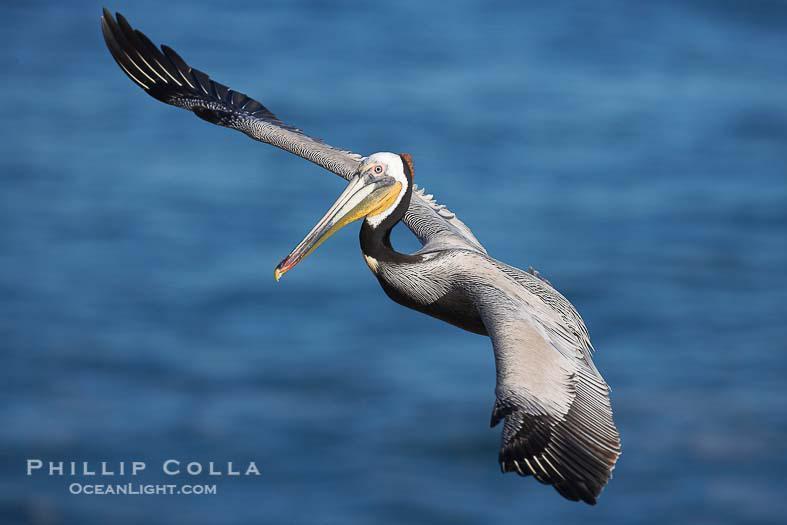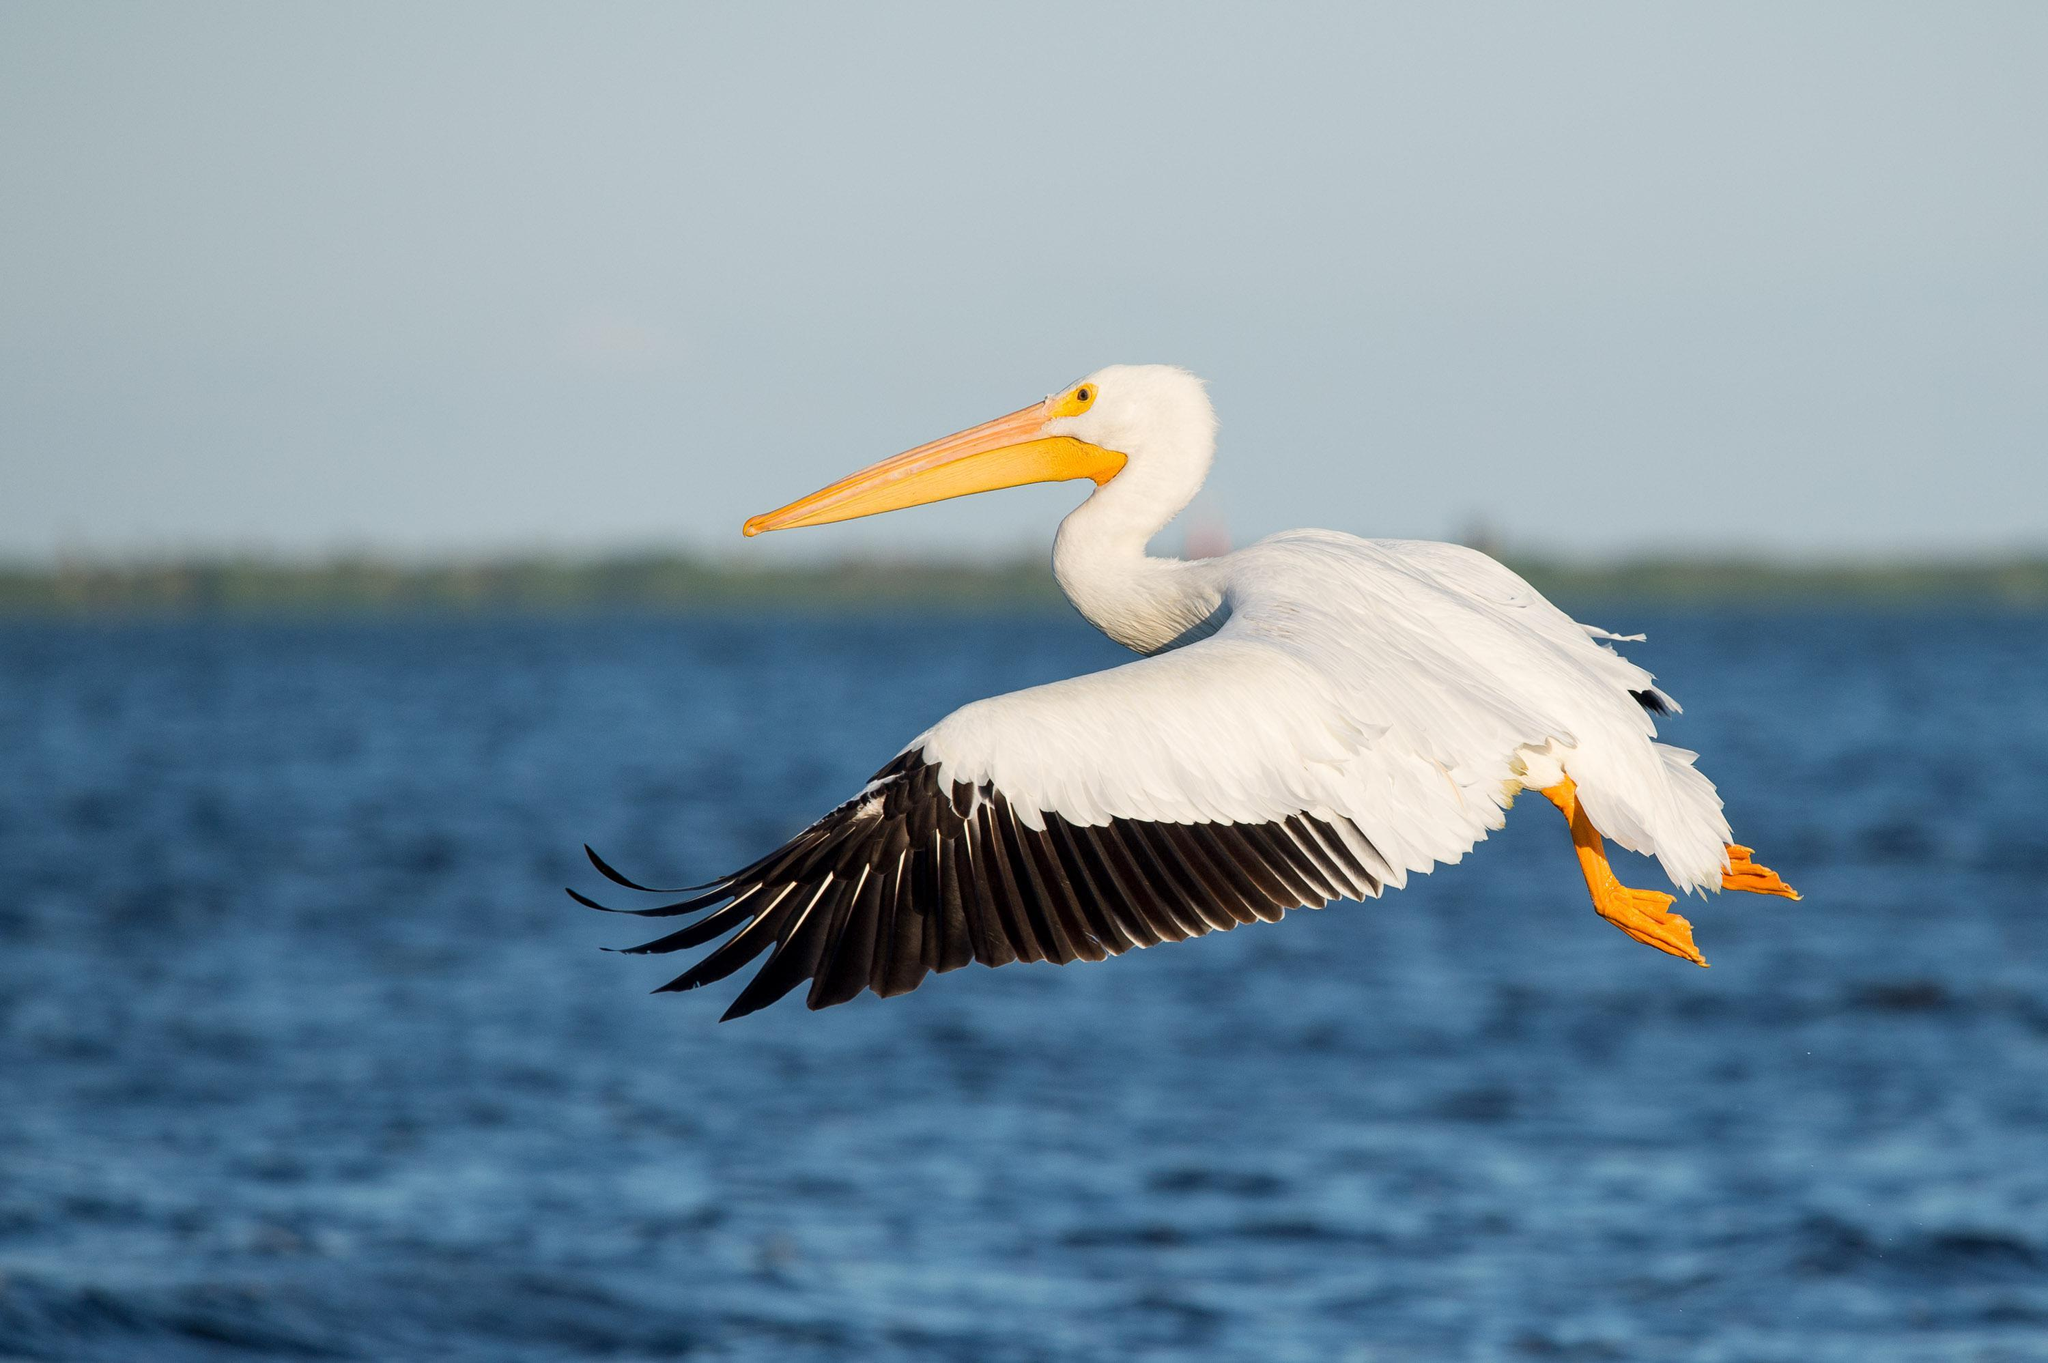The first image is the image on the left, the second image is the image on the right. Evaluate the accuracy of this statement regarding the images: "The bird in the image on the right is flying". Is it true? Answer yes or no. Yes. The first image is the image on the left, the second image is the image on the right. Assess this claim about the two images: "At least two pelicans are present in one of the images.". Correct or not? Answer yes or no. No. 